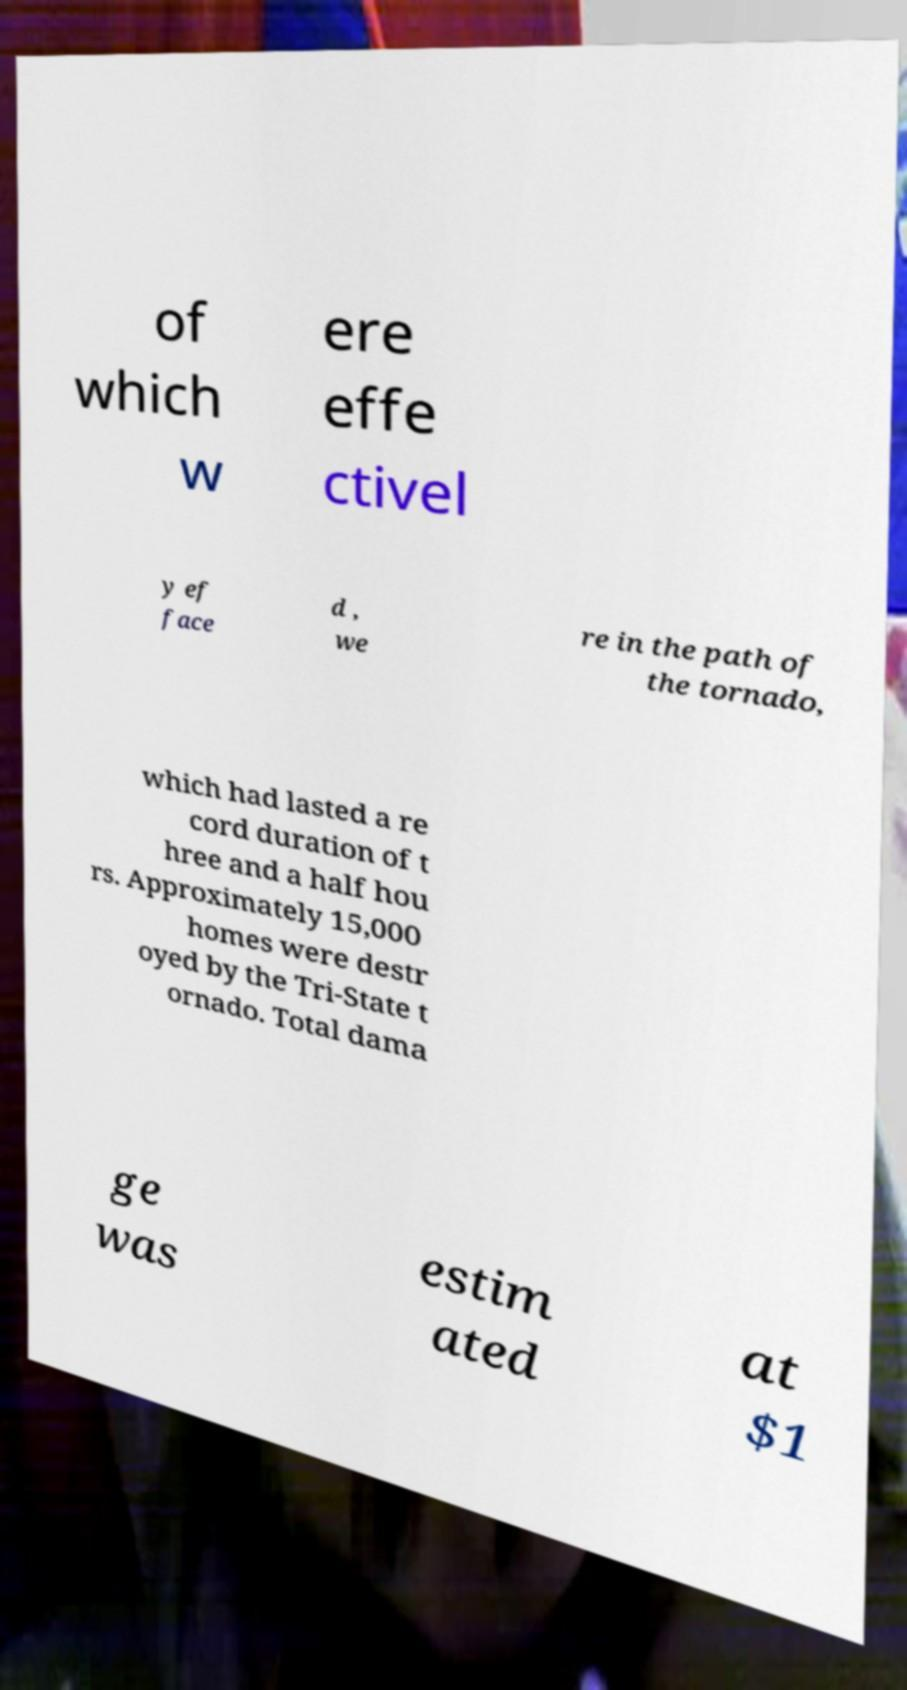Can you accurately transcribe the text from the provided image for me? of which w ere effe ctivel y ef face d , we re in the path of the tornado, which had lasted a re cord duration of t hree and a half hou rs. Approximately 15,000 homes were destr oyed by the Tri-State t ornado. Total dama ge was estim ated at $1 